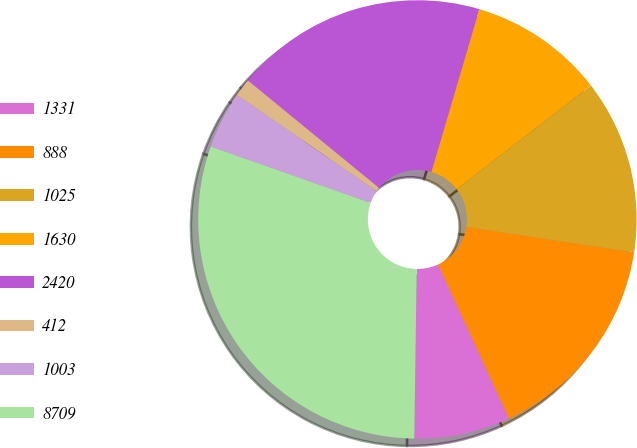Convert chart. <chart><loc_0><loc_0><loc_500><loc_500><pie_chart><fcel>1331<fcel>888<fcel>1025<fcel>1630<fcel>2420<fcel>412<fcel>1003<fcel>8709<nl><fcel>7.09%<fcel>15.74%<fcel>12.86%<fcel>9.98%<fcel>18.63%<fcel>1.32%<fcel>4.21%<fcel>30.17%<nl></chart> 